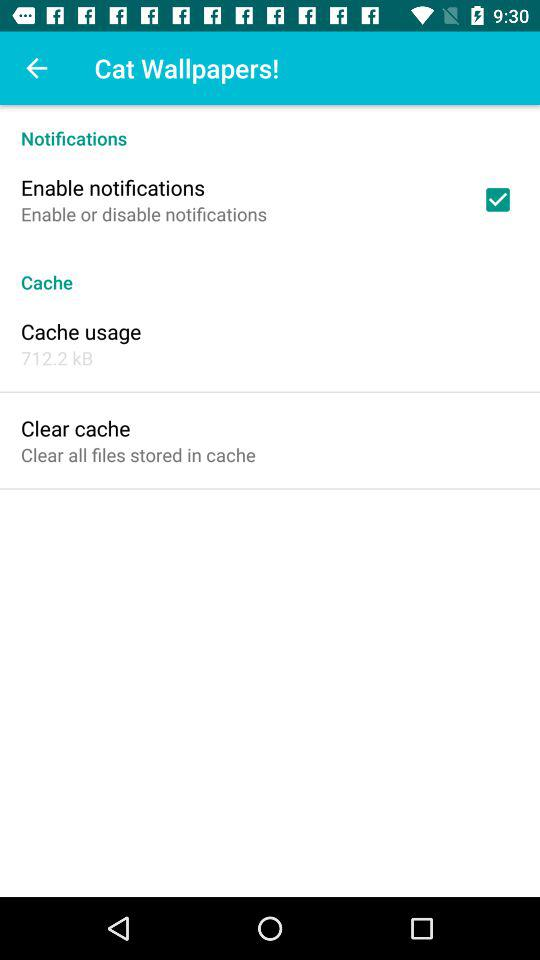What is the name of the application?
When the provided information is insufficient, respond with <no answer>. <no answer> 